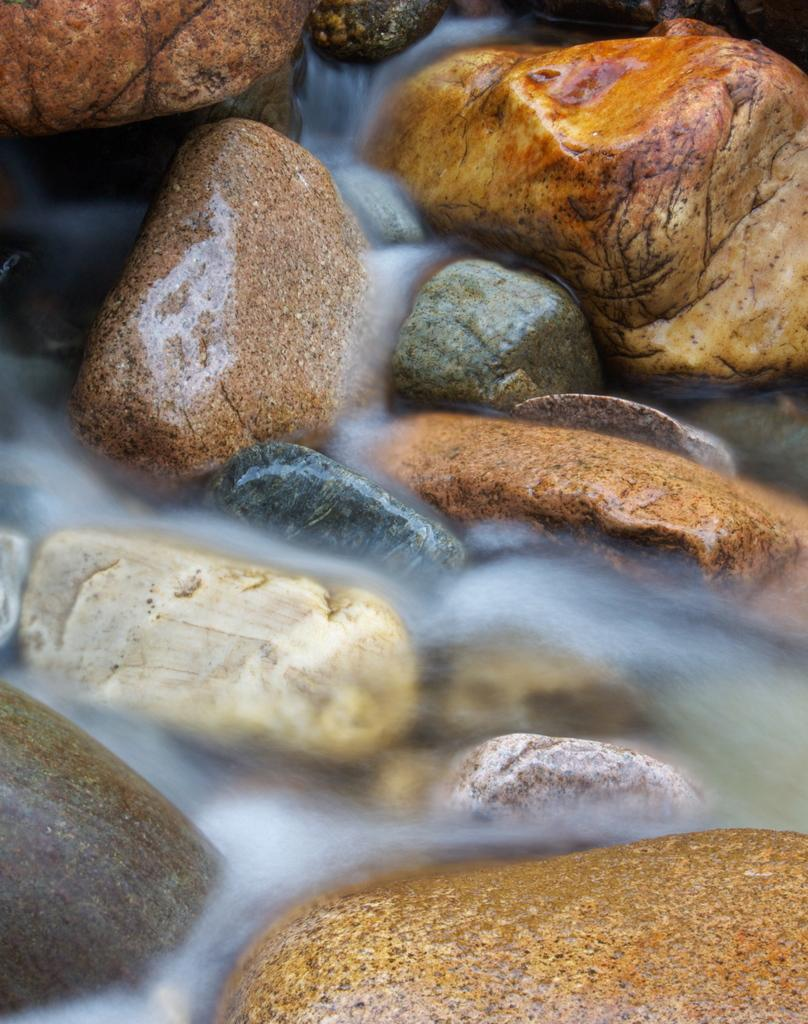What type of natural elements are present in the image? There are stones and water visible in the image. Can you describe the water in the image? The water is flowing in the image. What book is the water tricking into in the image? There is no book present in the image, and the water is not tricking into anything. 